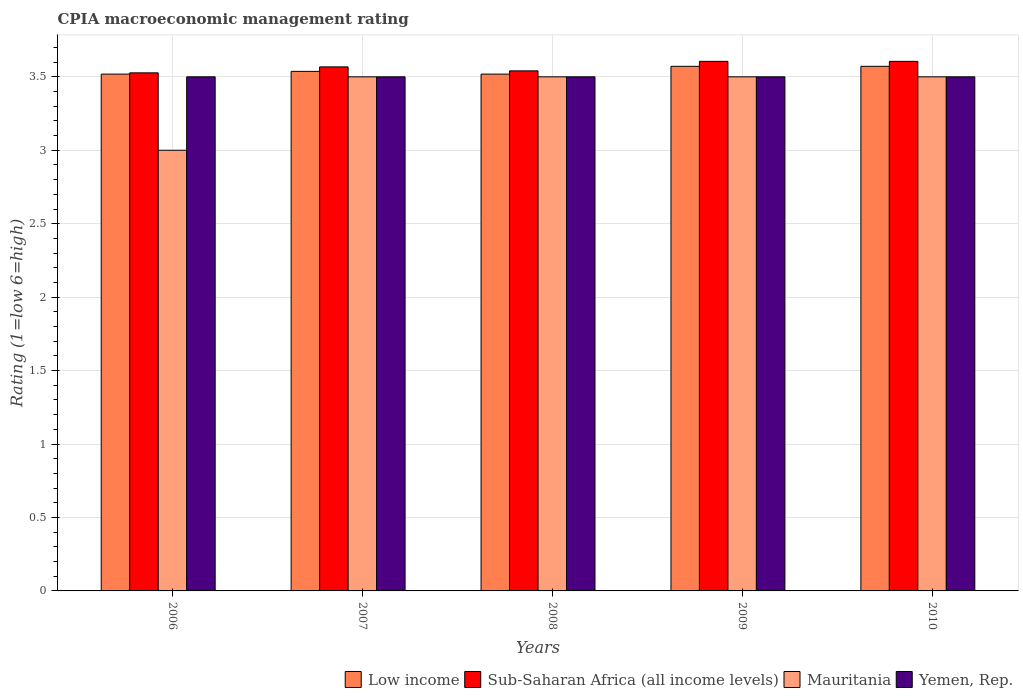Are the number of bars per tick equal to the number of legend labels?
Offer a very short reply. Yes. How many bars are there on the 3rd tick from the left?
Your response must be concise. 4. How many bars are there on the 2nd tick from the right?
Keep it short and to the point. 4. In how many cases, is the number of bars for a given year not equal to the number of legend labels?
Your answer should be very brief. 0. What is the CPIA rating in Low income in 2007?
Provide a succinct answer. 3.54. Across all years, what is the maximum CPIA rating in Sub-Saharan Africa (all income levels)?
Keep it short and to the point. 3.61. Across all years, what is the minimum CPIA rating in Sub-Saharan Africa (all income levels)?
Your answer should be very brief. 3.53. In which year was the CPIA rating in Mauritania minimum?
Provide a short and direct response. 2006. What is the total CPIA rating in Sub-Saharan Africa (all income levels) in the graph?
Give a very brief answer. 17.85. What is the difference between the CPIA rating in Sub-Saharan Africa (all income levels) in 2007 and that in 2008?
Ensure brevity in your answer.  0.03. What is the difference between the CPIA rating in Mauritania in 2010 and the CPIA rating in Sub-Saharan Africa (all income levels) in 2009?
Offer a terse response. -0.11. What is the average CPIA rating in Low income per year?
Ensure brevity in your answer.  3.54. In the year 2006, what is the difference between the CPIA rating in Mauritania and CPIA rating in Yemen, Rep.?
Your answer should be very brief. -0.5. In how many years, is the CPIA rating in Sub-Saharan Africa (all income levels) greater than 1.2?
Give a very brief answer. 5. What is the ratio of the CPIA rating in Mauritania in 2007 to that in 2010?
Give a very brief answer. 1. Is the CPIA rating in Yemen, Rep. in 2006 less than that in 2007?
Your answer should be very brief. No. Is the difference between the CPIA rating in Mauritania in 2009 and 2010 greater than the difference between the CPIA rating in Yemen, Rep. in 2009 and 2010?
Provide a succinct answer. No. What is the difference between the highest and the lowest CPIA rating in Sub-Saharan Africa (all income levels)?
Provide a short and direct response. 0.08. In how many years, is the CPIA rating in Mauritania greater than the average CPIA rating in Mauritania taken over all years?
Offer a very short reply. 4. Is the sum of the CPIA rating in Sub-Saharan Africa (all income levels) in 2009 and 2010 greater than the maximum CPIA rating in Yemen, Rep. across all years?
Offer a terse response. Yes. What does the 4th bar from the left in 2009 represents?
Give a very brief answer. Yemen, Rep. What does the 2nd bar from the right in 2006 represents?
Ensure brevity in your answer.  Mauritania. How many bars are there?
Your response must be concise. 20. Are all the bars in the graph horizontal?
Your answer should be very brief. No. How many legend labels are there?
Keep it short and to the point. 4. How are the legend labels stacked?
Your answer should be very brief. Horizontal. What is the title of the graph?
Your answer should be very brief. CPIA macroeconomic management rating. What is the label or title of the X-axis?
Your answer should be very brief. Years. What is the Rating (1=low 6=high) of Low income in 2006?
Make the answer very short. 3.52. What is the Rating (1=low 6=high) of Sub-Saharan Africa (all income levels) in 2006?
Your response must be concise. 3.53. What is the Rating (1=low 6=high) in Mauritania in 2006?
Your answer should be compact. 3. What is the Rating (1=low 6=high) in Yemen, Rep. in 2006?
Make the answer very short. 3.5. What is the Rating (1=low 6=high) in Low income in 2007?
Ensure brevity in your answer.  3.54. What is the Rating (1=low 6=high) of Sub-Saharan Africa (all income levels) in 2007?
Provide a succinct answer. 3.57. What is the Rating (1=low 6=high) of Low income in 2008?
Offer a very short reply. 3.52. What is the Rating (1=low 6=high) of Sub-Saharan Africa (all income levels) in 2008?
Your response must be concise. 3.54. What is the Rating (1=low 6=high) of Yemen, Rep. in 2008?
Make the answer very short. 3.5. What is the Rating (1=low 6=high) in Low income in 2009?
Your answer should be compact. 3.57. What is the Rating (1=low 6=high) of Sub-Saharan Africa (all income levels) in 2009?
Offer a terse response. 3.61. What is the Rating (1=low 6=high) of Low income in 2010?
Provide a short and direct response. 3.57. What is the Rating (1=low 6=high) of Sub-Saharan Africa (all income levels) in 2010?
Make the answer very short. 3.61. What is the Rating (1=low 6=high) of Yemen, Rep. in 2010?
Ensure brevity in your answer.  3.5. Across all years, what is the maximum Rating (1=low 6=high) in Low income?
Offer a terse response. 3.57. Across all years, what is the maximum Rating (1=low 6=high) of Sub-Saharan Africa (all income levels)?
Your response must be concise. 3.61. Across all years, what is the minimum Rating (1=low 6=high) of Low income?
Offer a very short reply. 3.52. Across all years, what is the minimum Rating (1=low 6=high) in Sub-Saharan Africa (all income levels)?
Provide a succinct answer. 3.53. Across all years, what is the minimum Rating (1=low 6=high) in Mauritania?
Keep it short and to the point. 3. Across all years, what is the minimum Rating (1=low 6=high) in Yemen, Rep.?
Give a very brief answer. 3.5. What is the total Rating (1=low 6=high) of Low income in the graph?
Your response must be concise. 17.72. What is the total Rating (1=low 6=high) in Sub-Saharan Africa (all income levels) in the graph?
Ensure brevity in your answer.  17.85. What is the total Rating (1=low 6=high) in Mauritania in the graph?
Make the answer very short. 17. What is the total Rating (1=low 6=high) in Yemen, Rep. in the graph?
Provide a short and direct response. 17.5. What is the difference between the Rating (1=low 6=high) in Low income in 2006 and that in 2007?
Provide a short and direct response. -0.02. What is the difference between the Rating (1=low 6=high) of Sub-Saharan Africa (all income levels) in 2006 and that in 2007?
Keep it short and to the point. -0.04. What is the difference between the Rating (1=low 6=high) of Low income in 2006 and that in 2008?
Make the answer very short. 0. What is the difference between the Rating (1=low 6=high) of Sub-Saharan Africa (all income levels) in 2006 and that in 2008?
Keep it short and to the point. -0.01. What is the difference between the Rating (1=low 6=high) in Mauritania in 2006 and that in 2008?
Ensure brevity in your answer.  -0.5. What is the difference between the Rating (1=low 6=high) of Yemen, Rep. in 2006 and that in 2008?
Make the answer very short. 0. What is the difference between the Rating (1=low 6=high) of Low income in 2006 and that in 2009?
Your response must be concise. -0.05. What is the difference between the Rating (1=low 6=high) of Sub-Saharan Africa (all income levels) in 2006 and that in 2009?
Your answer should be very brief. -0.08. What is the difference between the Rating (1=low 6=high) of Mauritania in 2006 and that in 2009?
Provide a succinct answer. -0.5. What is the difference between the Rating (1=low 6=high) of Yemen, Rep. in 2006 and that in 2009?
Your answer should be very brief. 0. What is the difference between the Rating (1=low 6=high) of Low income in 2006 and that in 2010?
Provide a short and direct response. -0.05. What is the difference between the Rating (1=low 6=high) of Sub-Saharan Africa (all income levels) in 2006 and that in 2010?
Make the answer very short. -0.08. What is the difference between the Rating (1=low 6=high) of Low income in 2007 and that in 2008?
Your answer should be very brief. 0.02. What is the difference between the Rating (1=low 6=high) in Sub-Saharan Africa (all income levels) in 2007 and that in 2008?
Ensure brevity in your answer.  0.03. What is the difference between the Rating (1=low 6=high) in Yemen, Rep. in 2007 and that in 2008?
Provide a short and direct response. 0. What is the difference between the Rating (1=low 6=high) in Low income in 2007 and that in 2009?
Ensure brevity in your answer.  -0.03. What is the difference between the Rating (1=low 6=high) of Sub-Saharan Africa (all income levels) in 2007 and that in 2009?
Offer a very short reply. -0.04. What is the difference between the Rating (1=low 6=high) of Mauritania in 2007 and that in 2009?
Ensure brevity in your answer.  0. What is the difference between the Rating (1=low 6=high) of Low income in 2007 and that in 2010?
Your response must be concise. -0.03. What is the difference between the Rating (1=low 6=high) in Sub-Saharan Africa (all income levels) in 2007 and that in 2010?
Offer a terse response. -0.04. What is the difference between the Rating (1=low 6=high) of Low income in 2008 and that in 2009?
Your response must be concise. -0.05. What is the difference between the Rating (1=low 6=high) of Sub-Saharan Africa (all income levels) in 2008 and that in 2009?
Offer a very short reply. -0.06. What is the difference between the Rating (1=low 6=high) in Yemen, Rep. in 2008 and that in 2009?
Make the answer very short. 0. What is the difference between the Rating (1=low 6=high) of Low income in 2008 and that in 2010?
Offer a terse response. -0.05. What is the difference between the Rating (1=low 6=high) of Sub-Saharan Africa (all income levels) in 2008 and that in 2010?
Provide a short and direct response. -0.06. What is the difference between the Rating (1=low 6=high) of Yemen, Rep. in 2008 and that in 2010?
Give a very brief answer. 0. What is the difference between the Rating (1=low 6=high) in Low income in 2009 and that in 2010?
Give a very brief answer. 0. What is the difference between the Rating (1=low 6=high) of Sub-Saharan Africa (all income levels) in 2009 and that in 2010?
Make the answer very short. 0. What is the difference between the Rating (1=low 6=high) in Mauritania in 2009 and that in 2010?
Keep it short and to the point. 0. What is the difference between the Rating (1=low 6=high) of Low income in 2006 and the Rating (1=low 6=high) of Sub-Saharan Africa (all income levels) in 2007?
Keep it short and to the point. -0.05. What is the difference between the Rating (1=low 6=high) in Low income in 2006 and the Rating (1=low 6=high) in Mauritania in 2007?
Your response must be concise. 0.02. What is the difference between the Rating (1=low 6=high) in Low income in 2006 and the Rating (1=low 6=high) in Yemen, Rep. in 2007?
Offer a very short reply. 0.02. What is the difference between the Rating (1=low 6=high) in Sub-Saharan Africa (all income levels) in 2006 and the Rating (1=low 6=high) in Mauritania in 2007?
Ensure brevity in your answer.  0.03. What is the difference between the Rating (1=low 6=high) of Sub-Saharan Africa (all income levels) in 2006 and the Rating (1=low 6=high) of Yemen, Rep. in 2007?
Make the answer very short. 0.03. What is the difference between the Rating (1=low 6=high) in Mauritania in 2006 and the Rating (1=low 6=high) in Yemen, Rep. in 2007?
Give a very brief answer. -0.5. What is the difference between the Rating (1=low 6=high) of Low income in 2006 and the Rating (1=low 6=high) of Sub-Saharan Africa (all income levels) in 2008?
Your response must be concise. -0.02. What is the difference between the Rating (1=low 6=high) in Low income in 2006 and the Rating (1=low 6=high) in Mauritania in 2008?
Your response must be concise. 0.02. What is the difference between the Rating (1=low 6=high) of Low income in 2006 and the Rating (1=low 6=high) of Yemen, Rep. in 2008?
Give a very brief answer. 0.02. What is the difference between the Rating (1=low 6=high) of Sub-Saharan Africa (all income levels) in 2006 and the Rating (1=low 6=high) of Mauritania in 2008?
Provide a succinct answer. 0.03. What is the difference between the Rating (1=low 6=high) of Sub-Saharan Africa (all income levels) in 2006 and the Rating (1=low 6=high) of Yemen, Rep. in 2008?
Make the answer very short. 0.03. What is the difference between the Rating (1=low 6=high) in Mauritania in 2006 and the Rating (1=low 6=high) in Yemen, Rep. in 2008?
Keep it short and to the point. -0.5. What is the difference between the Rating (1=low 6=high) in Low income in 2006 and the Rating (1=low 6=high) in Sub-Saharan Africa (all income levels) in 2009?
Provide a short and direct response. -0.09. What is the difference between the Rating (1=low 6=high) in Low income in 2006 and the Rating (1=low 6=high) in Mauritania in 2009?
Provide a succinct answer. 0.02. What is the difference between the Rating (1=low 6=high) of Low income in 2006 and the Rating (1=low 6=high) of Yemen, Rep. in 2009?
Give a very brief answer. 0.02. What is the difference between the Rating (1=low 6=high) of Sub-Saharan Africa (all income levels) in 2006 and the Rating (1=low 6=high) of Mauritania in 2009?
Ensure brevity in your answer.  0.03. What is the difference between the Rating (1=low 6=high) of Sub-Saharan Africa (all income levels) in 2006 and the Rating (1=low 6=high) of Yemen, Rep. in 2009?
Keep it short and to the point. 0.03. What is the difference between the Rating (1=low 6=high) in Low income in 2006 and the Rating (1=low 6=high) in Sub-Saharan Africa (all income levels) in 2010?
Provide a short and direct response. -0.09. What is the difference between the Rating (1=low 6=high) of Low income in 2006 and the Rating (1=low 6=high) of Mauritania in 2010?
Provide a succinct answer. 0.02. What is the difference between the Rating (1=low 6=high) in Low income in 2006 and the Rating (1=low 6=high) in Yemen, Rep. in 2010?
Provide a succinct answer. 0.02. What is the difference between the Rating (1=low 6=high) of Sub-Saharan Africa (all income levels) in 2006 and the Rating (1=low 6=high) of Mauritania in 2010?
Offer a terse response. 0.03. What is the difference between the Rating (1=low 6=high) in Sub-Saharan Africa (all income levels) in 2006 and the Rating (1=low 6=high) in Yemen, Rep. in 2010?
Your response must be concise. 0.03. What is the difference between the Rating (1=low 6=high) of Mauritania in 2006 and the Rating (1=low 6=high) of Yemen, Rep. in 2010?
Provide a short and direct response. -0.5. What is the difference between the Rating (1=low 6=high) of Low income in 2007 and the Rating (1=low 6=high) of Sub-Saharan Africa (all income levels) in 2008?
Offer a very short reply. -0. What is the difference between the Rating (1=low 6=high) in Low income in 2007 and the Rating (1=low 6=high) in Mauritania in 2008?
Make the answer very short. 0.04. What is the difference between the Rating (1=low 6=high) of Low income in 2007 and the Rating (1=low 6=high) of Yemen, Rep. in 2008?
Provide a succinct answer. 0.04. What is the difference between the Rating (1=low 6=high) of Sub-Saharan Africa (all income levels) in 2007 and the Rating (1=low 6=high) of Mauritania in 2008?
Ensure brevity in your answer.  0.07. What is the difference between the Rating (1=low 6=high) of Sub-Saharan Africa (all income levels) in 2007 and the Rating (1=low 6=high) of Yemen, Rep. in 2008?
Your answer should be compact. 0.07. What is the difference between the Rating (1=low 6=high) in Low income in 2007 and the Rating (1=low 6=high) in Sub-Saharan Africa (all income levels) in 2009?
Provide a short and direct response. -0.07. What is the difference between the Rating (1=low 6=high) of Low income in 2007 and the Rating (1=low 6=high) of Mauritania in 2009?
Offer a terse response. 0.04. What is the difference between the Rating (1=low 6=high) of Low income in 2007 and the Rating (1=low 6=high) of Yemen, Rep. in 2009?
Offer a very short reply. 0.04. What is the difference between the Rating (1=low 6=high) of Sub-Saharan Africa (all income levels) in 2007 and the Rating (1=low 6=high) of Mauritania in 2009?
Offer a very short reply. 0.07. What is the difference between the Rating (1=low 6=high) in Sub-Saharan Africa (all income levels) in 2007 and the Rating (1=low 6=high) in Yemen, Rep. in 2009?
Ensure brevity in your answer.  0.07. What is the difference between the Rating (1=low 6=high) in Mauritania in 2007 and the Rating (1=low 6=high) in Yemen, Rep. in 2009?
Provide a short and direct response. 0. What is the difference between the Rating (1=low 6=high) in Low income in 2007 and the Rating (1=low 6=high) in Sub-Saharan Africa (all income levels) in 2010?
Offer a very short reply. -0.07. What is the difference between the Rating (1=low 6=high) in Low income in 2007 and the Rating (1=low 6=high) in Mauritania in 2010?
Provide a short and direct response. 0.04. What is the difference between the Rating (1=low 6=high) of Low income in 2007 and the Rating (1=low 6=high) of Yemen, Rep. in 2010?
Keep it short and to the point. 0.04. What is the difference between the Rating (1=low 6=high) of Sub-Saharan Africa (all income levels) in 2007 and the Rating (1=low 6=high) of Mauritania in 2010?
Give a very brief answer. 0.07. What is the difference between the Rating (1=low 6=high) of Sub-Saharan Africa (all income levels) in 2007 and the Rating (1=low 6=high) of Yemen, Rep. in 2010?
Provide a succinct answer. 0.07. What is the difference between the Rating (1=low 6=high) of Mauritania in 2007 and the Rating (1=low 6=high) of Yemen, Rep. in 2010?
Ensure brevity in your answer.  0. What is the difference between the Rating (1=low 6=high) in Low income in 2008 and the Rating (1=low 6=high) in Sub-Saharan Africa (all income levels) in 2009?
Keep it short and to the point. -0.09. What is the difference between the Rating (1=low 6=high) in Low income in 2008 and the Rating (1=low 6=high) in Mauritania in 2009?
Offer a terse response. 0.02. What is the difference between the Rating (1=low 6=high) in Low income in 2008 and the Rating (1=low 6=high) in Yemen, Rep. in 2009?
Your answer should be very brief. 0.02. What is the difference between the Rating (1=low 6=high) of Sub-Saharan Africa (all income levels) in 2008 and the Rating (1=low 6=high) of Mauritania in 2009?
Your answer should be very brief. 0.04. What is the difference between the Rating (1=low 6=high) of Sub-Saharan Africa (all income levels) in 2008 and the Rating (1=low 6=high) of Yemen, Rep. in 2009?
Give a very brief answer. 0.04. What is the difference between the Rating (1=low 6=high) in Low income in 2008 and the Rating (1=low 6=high) in Sub-Saharan Africa (all income levels) in 2010?
Your answer should be very brief. -0.09. What is the difference between the Rating (1=low 6=high) of Low income in 2008 and the Rating (1=low 6=high) of Mauritania in 2010?
Provide a succinct answer. 0.02. What is the difference between the Rating (1=low 6=high) of Low income in 2008 and the Rating (1=low 6=high) of Yemen, Rep. in 2010?
Provide a short and direct response. 0.02. What is the difference between the Rating (1=low 6=high) of Sub-Saharan Africa (all income levels) in 2008 and the Rating (1=low 6=high) of Mauritania in 2010?
Your response must be concise. 0.04. What is the difference between the Rating (1=low 6=high) of Sub-Saharan Africa (all income levels) in 2008 and the Rating (1=low 6=high) of Yemen, Rep. in 2010?
Offer a terse response. 0.04. What is the difference between the Rating (1=low 6=high) in Low income in 2009 and the Rating (1=low 6=high) in Sub-Saharan Africa (all income levels) in 2010?
Offer a very short reply. -0.03. What is the difference between the Rating (1=low 6=high) in Low income in 2009 and the Rating (1=low 6=high) in Mauritania in 2010?
Make the answer very short. 0.07. What is the difference between the Rating (1=low 6=high) of Low income in 2009 and the Rating (1=low 6=high) of Yemen, Rep. in 2010?
Offer a very short reply. 0.07. What is the difference between the Rating (1=low 6=high) in Sub-Saharan Africa (all income levels) in 2009 and the Rating (1=low 6=high) in Mauritania in 2010?
Provide a short and direct response. 0.11. What is the difference between the Rating (1=low 6=high) in Sub-Saharan Africa (all income levels) in 2009 and the Rating (1=low 6=high) in Yemen, Rep. in 2010?
Provide a succinct answer. 0.11. What is the difference between the Rating (1=low 6=high) of Mauritania in 2009 and the Rating (1=low 6=high) of Yemen, Rep. in 2010?
Your answer should be very brief. 0. What is the average Rating (1=low 6=high) of Low income per year?
Ensure brevity in your answer.  3.54. What is the average Rating (1=low 6=high) in Sub-Saharan Africa (all income levels) per year?
Provide a short and direct response. 3.57. In the year 2006, what is the difference between the Rating (1=low 6=high) in Low income and Rating (1=low 6=high) in Sub-Saharan Africa (all income levels)?
Offer a terse response. -0.01. In the year 2006, what is the difference between the Rating (1=low 6=high) in Low income and Rating (1=low 6=high) in Mauritania?
Give a very brief answer. 0.52. In the year 2006, what is the difference between the Rating (1=low 6=high) in Low income and Rating (1=low 6=high) in Yemen, Rep.?
Your answer should be compact. 0.02. In the year 2006, what is the difference between the Rating (1=low 6=high) in Sub-Saharan Africa (all income levels) and Rating (1=low 6=high) in Mauritania?
Your answer should be very brief. 0.53. In the year 2006, what is the difference between the Rating (1=low 6=high) of Sub-Saharan Africa (all income levels) and Rating (1=low 6=high) of Yemen, Rep.?
Keep it short and to the point. 0.03. In the year 2006, what is the difference between the Rating (1=low 6=high) of Mauritania and Rating (1=low 6=high) of Yemen, Rep.?
Provide a short and direct response. -0.5. In the year 2007, what is the difference between the Rating (1=low 6=high) in Low income and Rating (1=low 6=high) in Sub-Saharan Africa (all income levels)?
Make the answer very short. -0.03. In the year 2007, what is the difference between the Rating (1=low 6=high) of Low income and Rating (1=low 6=high) of Mauritania?
Your response must be concise. 0.04. In the year 2007, what is the difference between the Rating (1=low 6=high) in Low income and Rating (1=low 6=high) in Yemen, Rep.?
Provide a short and direct response. 0.04. In the year 2007, what is the difference between the Rating (1=low 6=high) in Sub-Saharan Africa (all income levels) and Rating (1=low 6=high) in Mauritania?
Your response must be concise. 0.07. In the year 2007, what is the difference between the Rating (1=low 6=high) in Sub-Saharan Africa (all income levels) and Rating (1=low 6=high) in Yemen, Rep.?
Offer a very short reply. 0.07. In the year 2007, what is the difference between the Rating (1=low 6=high) in Mauritania and Rating (1=low 6=high) in Yemen, Rep.?
Keep it short and to the point. 0. In the year 2008, what is the difference between the Rating (1=low 6=high) in Low income and Rating (1=low 6=high) in Sub-Saharan Africa (all income levels)?
Offer a terse response. -0.02. In the year 2008, what is the difference between the Rating (1=low 6=high) in Low income and Rating (1=low 6=high) in Mauritania?
Offer a terse response. 0.02. In the year 2008, what is the difference between the Rating (1=low 6=high) of Low income and Rating (1=low 6=high) of Yemen, Rep.?
Keep it short and to the point. 0.02. In the year 2008, what is the difference between the Rating (1=low 6=high) in Sub-Saharan Africa (all income levels) and Rating (1=low 6=high) in Mauritania?
Provide a succinct answer. 0.04. In the year 2008, what is the difference between the Rating (1=low 6=high) of Sub-Saharan Africa (all income levels) and Rating (1=low 6=high) of Yemen, Rep.?
Your response must be concise. 0.04. In the year 2009, what is the difference between the Rating (1=low 6=high) of Low income and Rating (1=low 6=high) of Sub-Saharan Africa (all income levels)?
Your response must be concise. -0.03. In the year 2009, what is the difference between the Rating (1=low 6=high) of Low income and Rating (1=low 6=high) of Mauritania?
Offer a very short reply. 0.07. In the year 2009, what is the difference between the Rating (1=low 6=high) in Low income and Rating (1=low 6=high) in Yemen, Rep.?
Ensure brevity in your answer.  0.07. In the year 2009, what is the difference between the Rating (1=low 6=high) of Sub-Saharan Africa (all income levels) and Rating (1=low 6=high) of Mauritania?
Offer a terse response. 0.11. In the year 2009, what is the difference between the Rating (1=low 6=high) of Sub-Saharan Africa (all income levels) and Rating (1=low 6=high) of Yemen, Rep.?
Offer a terse response. 0.11. In the year 2009, what is the difference between the Rating (1=low 6=high) in Mauritania and Rating (1=low 6=high) in Yemen, Rep.?
Provide a short and direct response. 0. In the year 2010, what is the difference between the Rating (1=low 6=high) of Low income and Rating (1=low 6=high) of Sub-Saharan Africa (all income levels)?
Keep it short and to the point. -0.03. In the year 2010, what is the difference between the Rating (1=low 6=high) in Low income and Rating (1=low 6=high) in Mauritania?
Ensure brevity in your answer.  0.07. In the year 2010, what is the difference between the Rating (1=low 6=high) of Low income and Rating (1=low 6=high) of Yemen, Rep.?
Keep it short and to the point. 0.07. In the year 2010, what is the difference between the Rating (1=low 6=high) in Sub-Saharan Africa (all income levels) and Rating (1=low 6=high) in Mauritania?
Give a very brief answer. 0.11. In the year 2010, what is the difference between the Rating (1=low 6=high) of Sub-Saharan Africa (all income levels) and Rating (1=low 6=high) of Yemen, Rep.?
Your answer should be very brief. 0.11. In the year 2010, what is the difference between the Rating (1=low 6=high) in Mauritania and Rating (1=low 6=high) in Yemen, Rep.?
Offer a terse response. 0. What is the ratio of the Rating (1=low 6=high) of Low income in 2006 to that in 2007?
Give a very brief answer. 0.99. What is the ratio of the Rating (1=low 6=high) of Sub-Saharan Africa (all income levels) in 2006 to that in 2007?
Make the answer very short. 0.99. What is the ratio of the Rating (1=low 6=high) of Mauritania in 2006 to that in 2007?
Your answer should be compact. 0.86. What is the ratio of the Rating (1=low 6=high) of Yemen, Rep. in 2006 to that in 2007?
Offer a very short reply. 1. What is the ratio of the Rating (1=low 6=high) in Sub-Saharan Africa (all income levels) in 2006 to that in 2008?
Make the answer very short. 1. What is the ratio of the Rating (1=low 6=high) of Low income in 2006 to that in 2009?
Provide a short and direct response. 0.99. What is the ratio of the Rating (1=low 6=high) of Sub-Saharan Africa (all income levels) in 2006 to that in 2009?
Give a very brief answer. 0.98. What is the ratio of the Rating (1=low 6=high) of Yemen, Rep. in 2006 to that in 2009?
Provide a short and direct response. 1. What is the ratio of the Rating (1=low 6=high) in Low income in 2006 to that in 2010?
Provide a succinct answer. 0.99. What is the ratio of the Rating (1=low 6=high) of Sub-Saharan Africa (all income levels) in 2006 to that in 2010?
Your answer should be compact. 0.98. What is the ratio of the Rating (1=low 6=high) in Yemen, Rep. in 2006 to that in 2010?
Ensure brevity in your answer.  1. What is the ratio of the Rating (1=low 6=high) in Low income in 2007 to that in 2008?
Ensure brevity in your answer.  1.01. What is the ratio of the Rating (1=low 6=high) of Sub-Saharan Africa (all income levels) in 2007 to that in 2008?
Provide a short and direct response. 1.01. What is the ratio of the Rating (1=low 6=high) in Sub-Saharan Africa (all income levels) in 2007 to that in 2009?
Provide a succinct answer. 0.99. What is the ratio of the Rating (1=low 6=high) in Mauritania in 2007 to that in 2009?
Make the answer very short. 1. What is the ratio of the Rating (1=low 6=high) in Yemen, Rep. in 2007 to that in 2009?
Give a very brief answer. 1. What is the ratio of the Rating (1=low 6=high) of Low income in 2007 to that in 2010?
Ensure brevity in your answer.  0.99. What is the ratio of the Rating (1=low 6=high) in Sub-Saharan Africa (all income levels) in 2007 to that in 2010?
Offer a very short reply. 0.99. What is the ratio of the Rating (1=low 6=high) of Mauritania in 2007 to that in 2010?
Provide a succinct answer. 1. What is the ratio of the Rating (1=low 6=high) in Yemen, Rep. in 2007 to that in 2010?
Give a very brief answer. 1. What is the ratio of the Rating (1=low 6=high) in Low income in 2008 to that in 2009?
Your answer should be very brief. 0.99. What is the ratio of the Rating (1=low 6=high) in Yemen, Rep. in 2008 to that in 2009?
Provide a short and direct response. 1. What is the ratio of the Rating (1=low 6=high) of Low income in 2008 to that in 2010?
Provide a succinct answer. 0.99. What is the ratio of the Rating (1=low 6=high) in Mauritania in 2008 to that in 2010?
Make the answer very short. 1. What is the ratio of the Rating (1=low 6=high) of Yemen, Rep. in 2008 to that in 2010?
Make the answer very short. 1. What is the ratio of the Rating (1=low 6=high) in Low income in 2009 to that in 2010?
Keep it short and to the point. 1. What is the ratio of the Rating (1=low 6=high) in Sub-Saharan Africa (all income levels) in 2009 to that in 2010?
Your answer should be very brief. 1. What is the ratio of the Rating (1=low 6=high) in Yemen, Rep. in 2009 to that in 2010?
Your answer should be very brief. 1. What is the difference between the highest and the second highest Rating (1=low 6=high) of Low income?
Make the answer very short. 0. What is the difference between the highest and the second highest Rating (1=low 6=high) in Sub-Saharan Africa (all income levels)?
Your response must be concise. 0. What is the difference between the highest and the second highest Rating (1=low 6=high) of Yemen, Rep.?
Provide a succinct answer. 0. What is the difference between the highest and the lowest Rating (1=low 6=high) in Low income?
Offer a terse response. 0.05. What is the difference between the highest and the lowest Rating (1=low 6=high) in Sub-Saharan Africa (all income levels)?
Offer a very short reply. 0.08. 